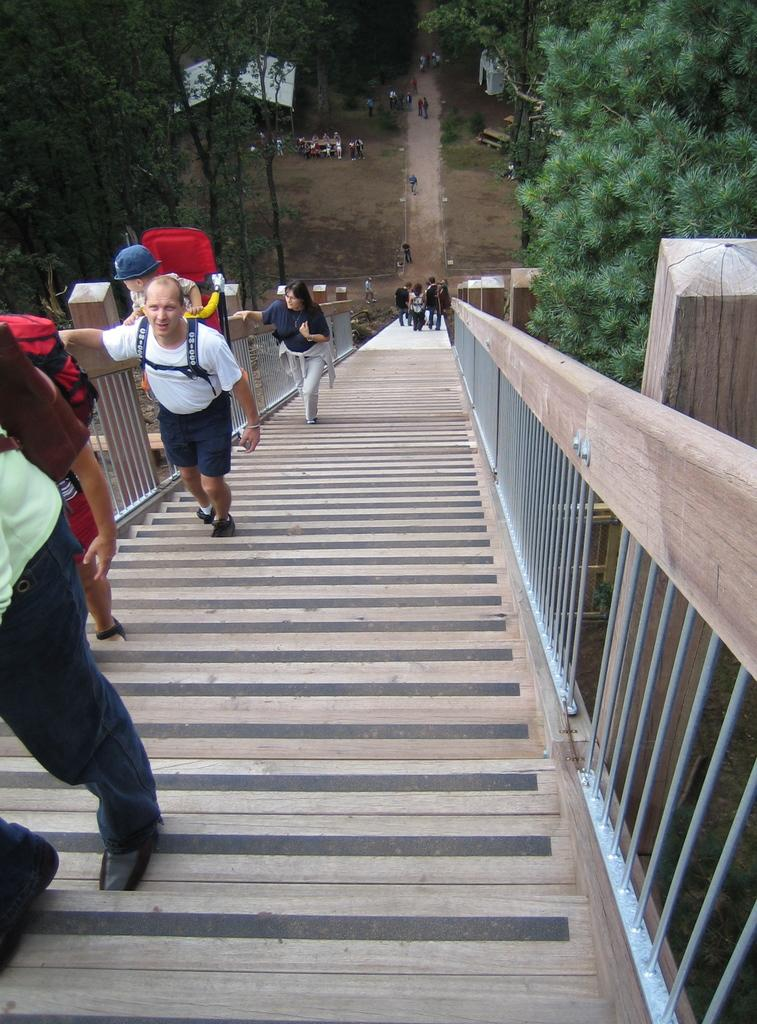What is the main subject of the image? The main subject of the image is a group of people. What can be seen in the sky in the image? Stars are visible in the image. What type of temporary shelters are present in the image? Tents are present in the image. What type of seating is available in the image? Benches are present in the image. What type of natural scenery is visible in the background of the image? Trees are visible in the background of the image. Where is the throne located in the image? There is no throne present in the image. How does the group of people say good-bye to each other in the image? The image does not show the group of people saying good-bye to each other. 